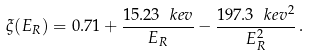<formula> <loc_0><loc_0><loc_500><loc_500>\xi ( E _ { R } ) = 0 . 7 1 + \frac { 1 5 . 2 3 \ k e v } { E _ { R } } - \frac { 1 9 7 . 3 \ k e v ^ { 2 } } { E _ { R } ^ { 2 } } \, .</formula> 